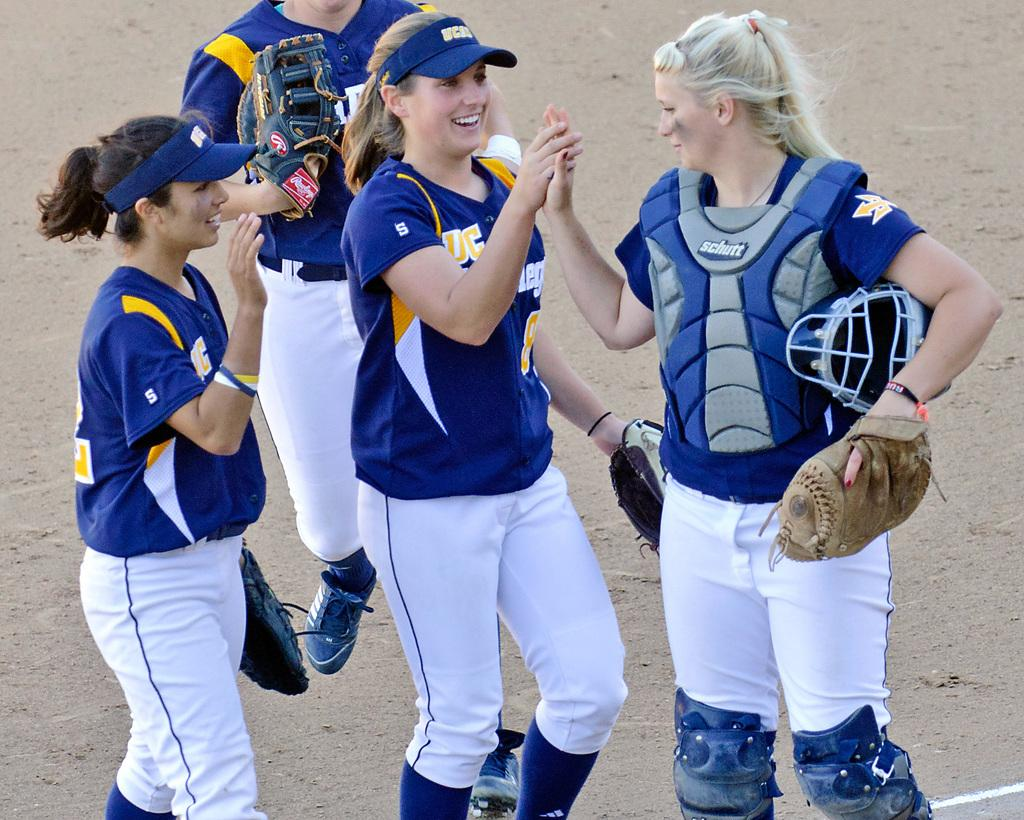What is the primary subject of the image? The primary subject of the image is women. What are the women doing in the image? The women are standing on a surface and smiling. Is there any specific action being performed by one of the women? Yes, one of the women is jumping. What type of nerve can be seen in the image? There is no nerve present in the image; it features women standing, smiling, and jumping. Can you tell me how many rakes are visible in the image? There are no rakes present in the image. 